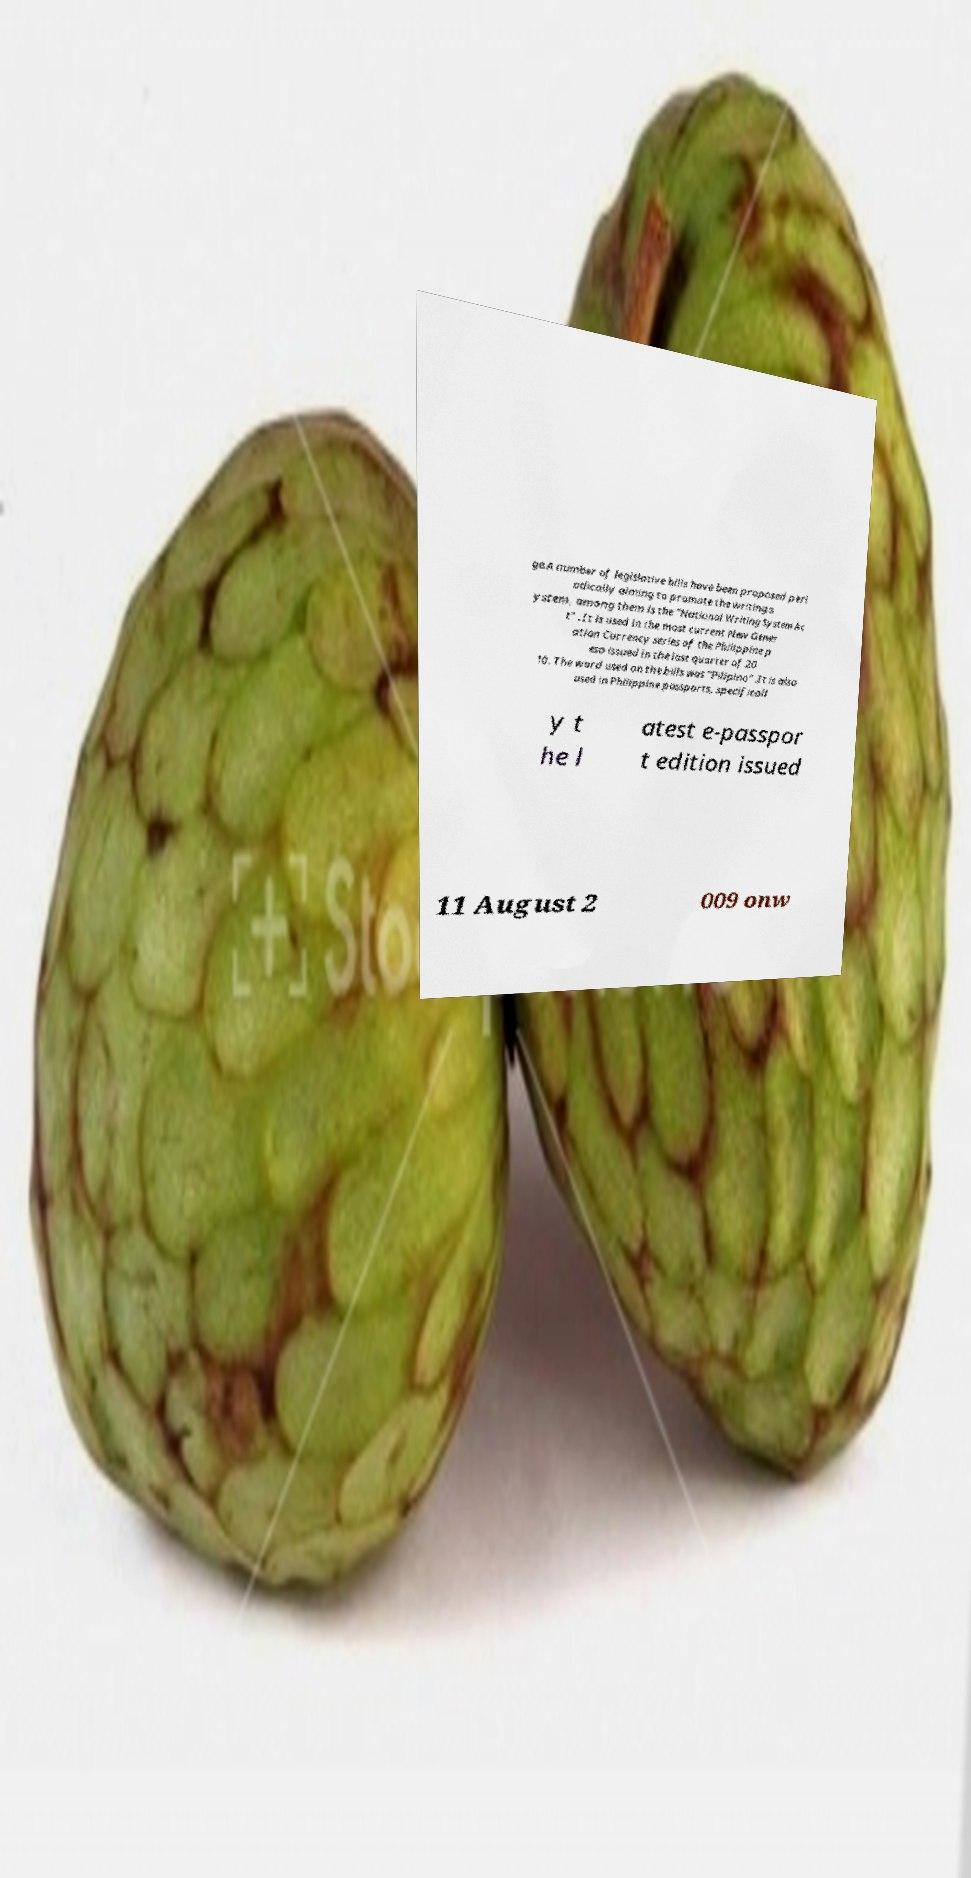Please read and relay the text visible in this image. What does it say? ge.A number of legislative bills have been proposed peri odically aiming to promote the writing s ystem, among them is the "National Writing System Ac t" . It is used in the most current New Gener ation Currency series of the Philippine p eso issued in the last quarter of 20 10. The word used on the bills was "Pilipino" .It is also used in Philippine passports, specificall y t he l atest e-passpor t edition issued 11 August 2 009 onw 